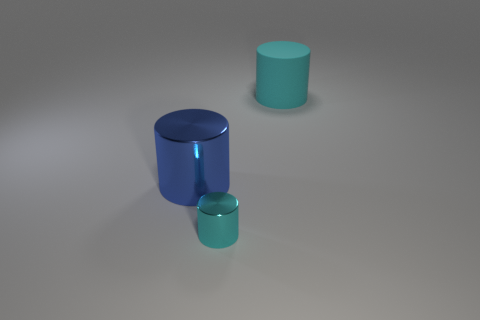Add 1 big metal cylinders. How many objects exist? 4 Subtract all metal cylinders. How many cylinders are left? 1 Add 2 blue objects. How many blue objects exist? 3 Subtract all cyan cylinders. How many cylinders are left? 1 Subtract 0 cyan balls. How many objects are left? 3 Subtract 2 cylinders. How many cylinders are left? 1 Subtract all purple cylinders. Subtract all green spheres. How many cylinders are left? 3 Subtract all brown spheres. How many cyan cylinders are left? 2 Subtract all large blue cylinders. Subtract all tiny cyan shiny cylinders. How many objects are left? 1 Add 1 big cyan rubber cylinders. How many big cyan rubber cylinders are left? 2 